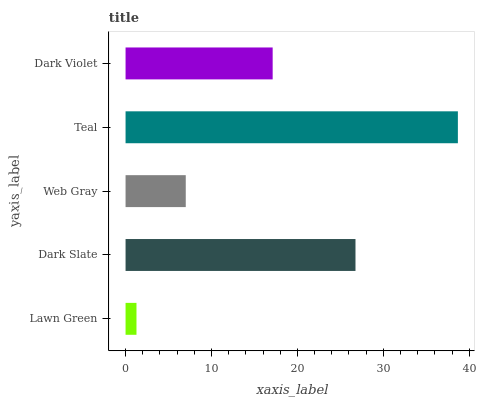Is Lawn Green the minimum?
Answer yes or no. Yes. Is Teal the maximum?
Answer yes or no. Yes. Is Dark Slate the minimum?
Answer yes or no. No. Is Dark Slate the maximum?
Answer yes or no. No. Is Dark Slate greater than Lawn Green?
Answer yes or no. Yes. Is Lawn Green less than Dark Slate?
Answer yes or no. Yes. Is Lawn Green greater than Dark Slate?
Answer yes or no. No. Is Dark Slate less than Lawn Green?
Answer yes or no. No. Is Dark Violet the high median?
Answer yes or no. Yes. Is Dark Violet the low median?
Answer yes or no. Yes. Is Dark Slate the high median?
Answer yes or no. No. Is Dark Slate the low median?
Answer yes or no. No. 